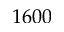Convert formula to latex. <formula><loc_0><loc_0><loc_500><loc_500>1 6 0 0</formula> 